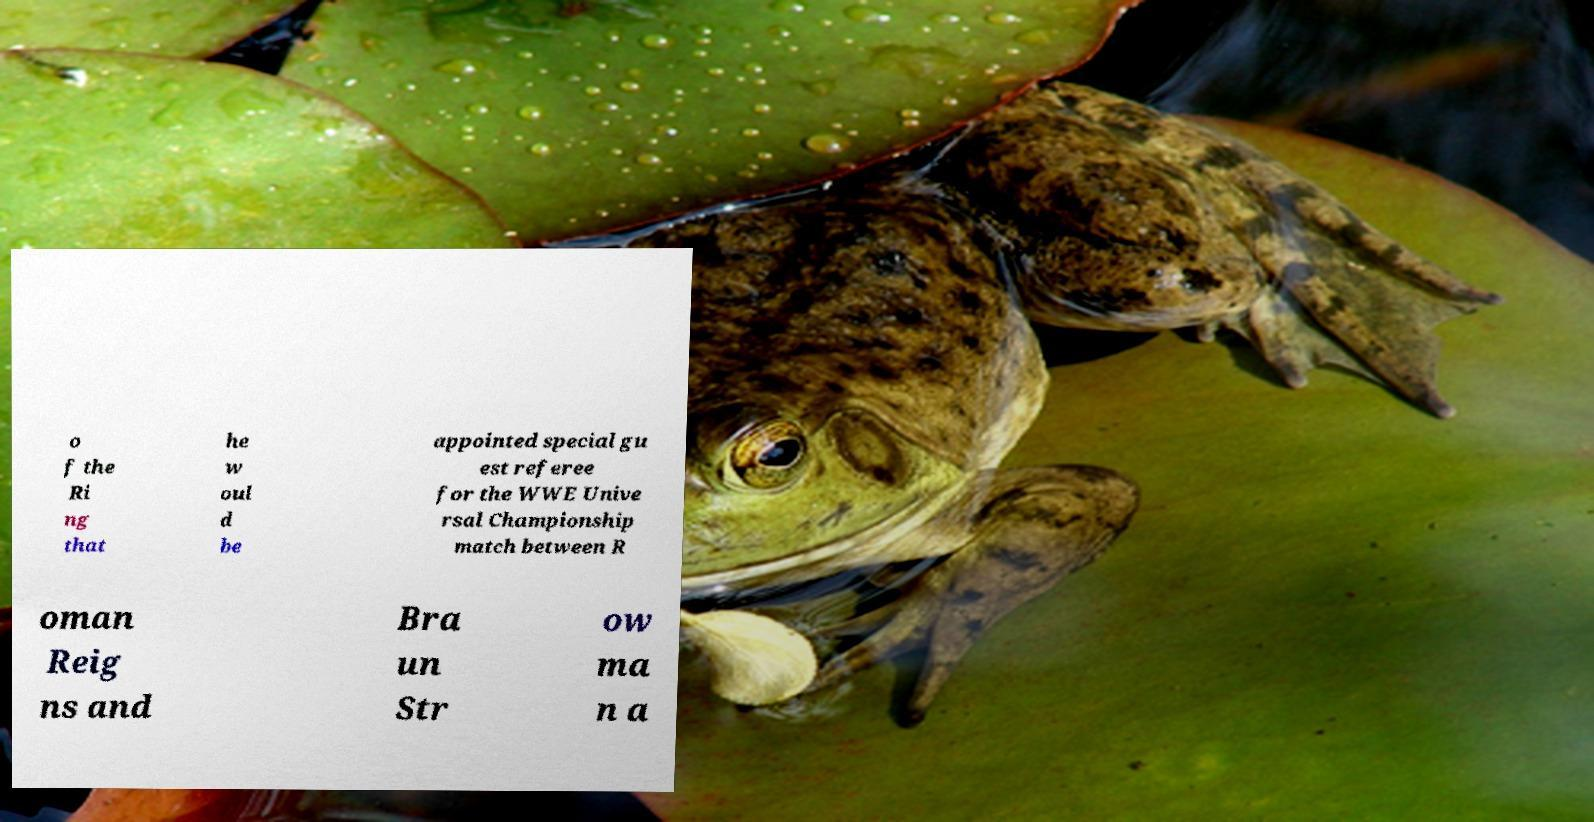Could you extract and type out the text from this image? o f the Ri ng that he w oul d be appointed special gu est referee for the WWE Unive rsal Championship match between R oman Reig ns and Bra un Str ow ma n a 